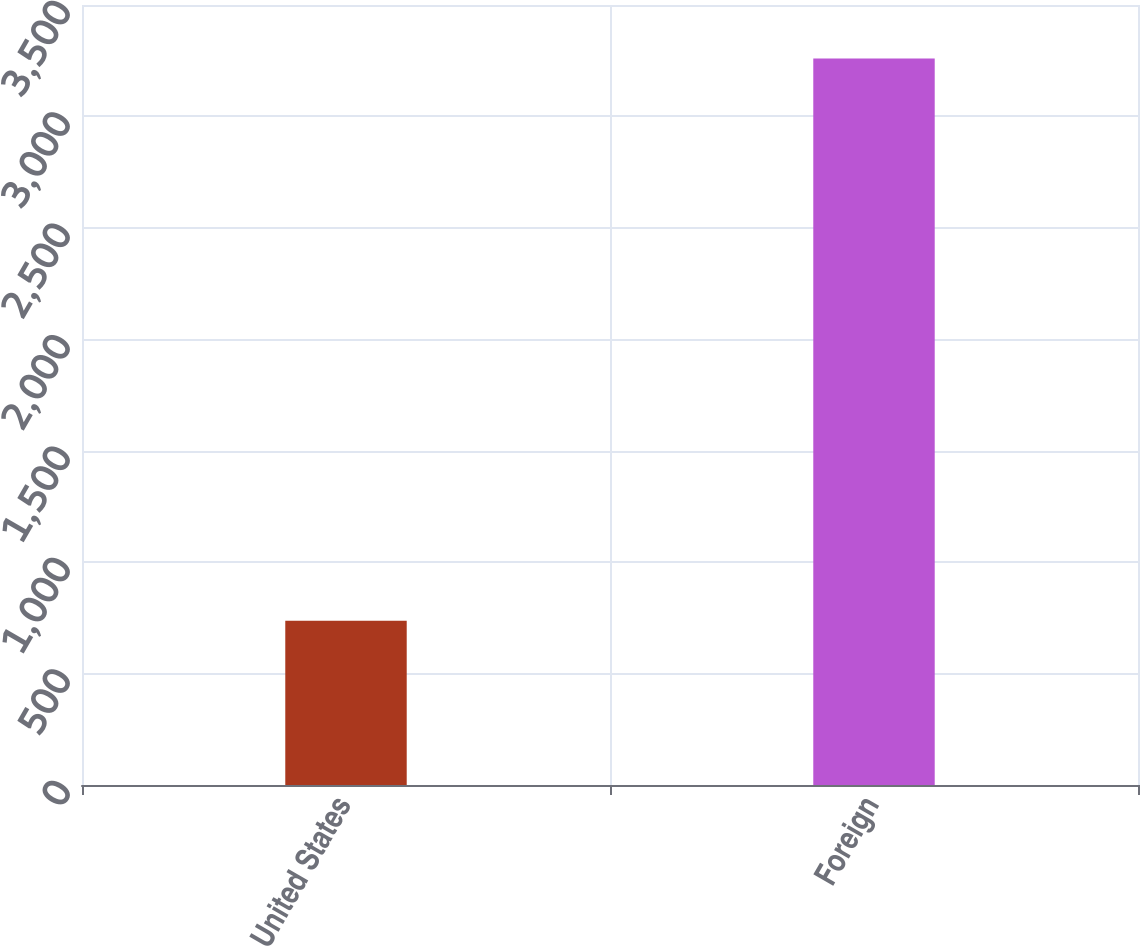<chart> <loc_0><loc_0><loc_500><loc_500><bar_chart><fcel>United States<fcel>Foreign<nl><fcel>737<fcel>3260<nl></chart> 